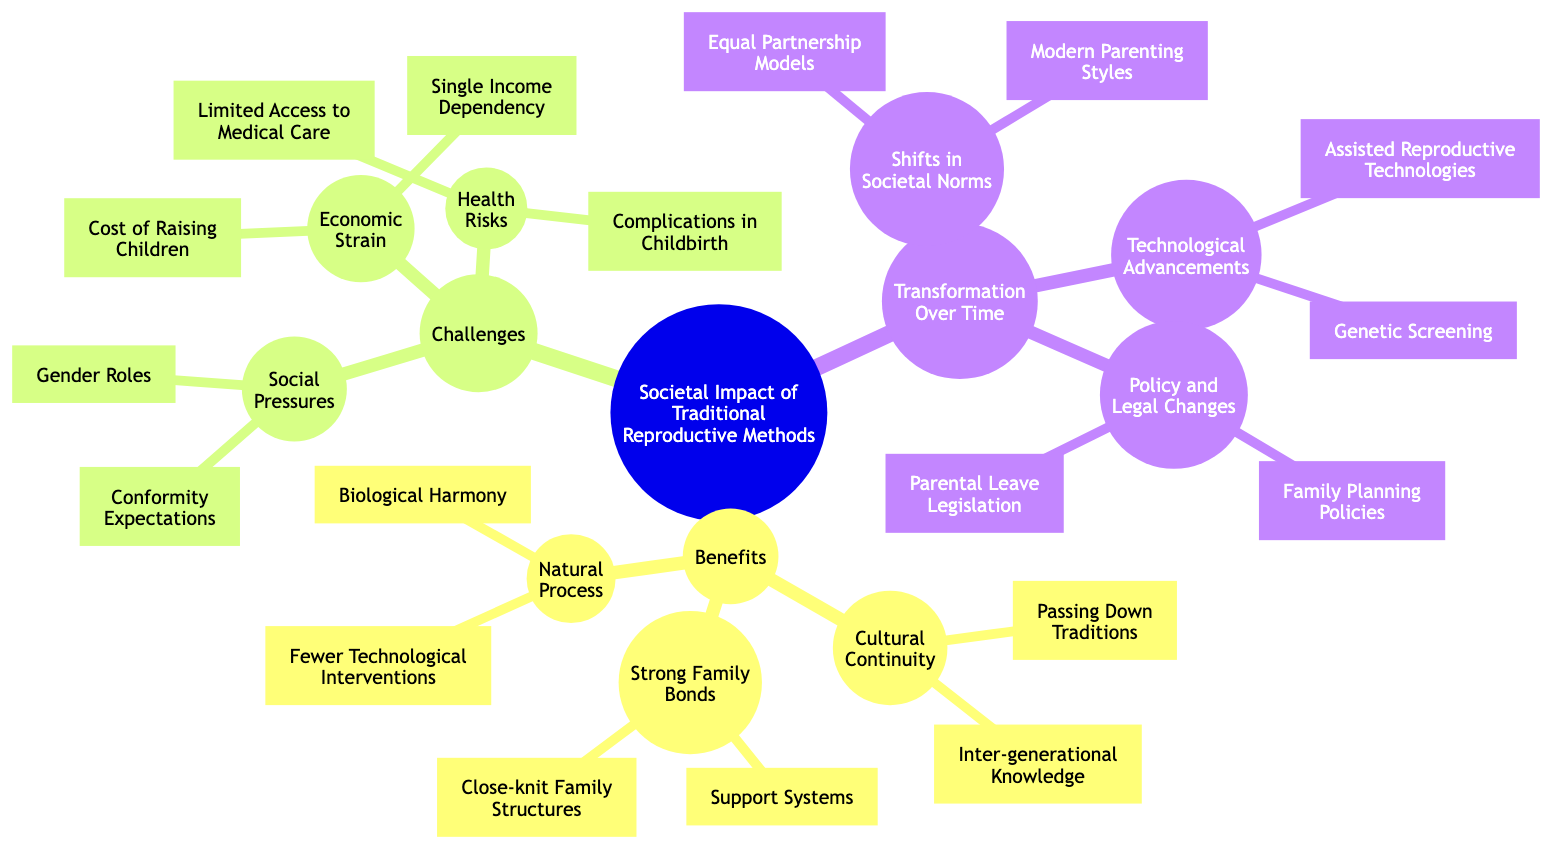What are the three main categories of societal impact of traditional reproductive methods? The diagram specifies three main categories: Benefits, Challenges, and Transformation Over Time. Each of these categories has sub-elements that provide further details.
Answer: Benefits, Challenges, Transformation Over Time How many sub-elements are there under "Challenges of Traditional Reproductive Methods"? The "Challenges of Traditional Reproductive Methods" category includes three sub-elements: Social Pressures, Health Risks, and Economic Strain. Therefore, the total number of sub-elements is three.
Answer: 3 What is one example of "Cultural Continuity" under the benefits? The benefits list "Cultural Continuity" which includes sub-elements such as "Passing Down Traditions" and "Inter-generational Knowledge." Therefore, one example is "Passing Down Traditions."
Answer: Passing Down Traditions What are the two types of challenges highlighted under "Health Risks"? The "Health Risks" subcategory comprises two specific challenges: "Complications in Childbirth" and "Limited Access to Medical Care." Thus, the answer includes both types of challenges.
Answer: Complications in Childbirth, Limited Access to Medical Care Which element shows the connection to "Modern Parenting Styles" and what category is it under? "Modern Parenting Styles" is found under the "Transformation Over Time" category, specifically within the sub-element "Shifts in Societal Norms." This identifies both the main category and the specific element showing the connection.
Answer: Shifts in Societal Norms What are two technological advancements mentioned in the diagram? The diagram highlights two technological advancements: "Assisted Reproductive Technologies" and "Genetic Screening." These advancements are crucial factors in reviewing the transformation of reproductive methods.
Answer: Assisted Reproductive Technologies, Genetic Screening How does "Economic Strain" relate to traditional reproductive methods? "Economic Strain" is one of the challenges identified in the diagram, with sub-elements that discuss costs associated with child-rearing, such as "Cost of Raising Children" and "Single Income Dependency." This indicates the financial burdens that traditional methods can impose on families.
Answer: Cost of Raising Children, Single Income Dependency What is one benefit associated with the "Natural Process" of traditional reproductive methods? The "Natural Process" category lists "Biological Harmony" and "Fewer Technological Interventions" as benefits. Therefore, one benefit linked to this category is "Biological Harmony."
Answer: Biological Harmony What legal changes are mentioned under "Policy and Legal Changes"? Under the category "Policy and Legal Changes," the diagram specifies "Family Planning Policies" and "Parental Leave Legislation" as the key legal changes impacting traditional reproductive methods. Thus, the answer includes both mentioned changes.
Answer: Family Planning Policies, Parental Leave Legislation 